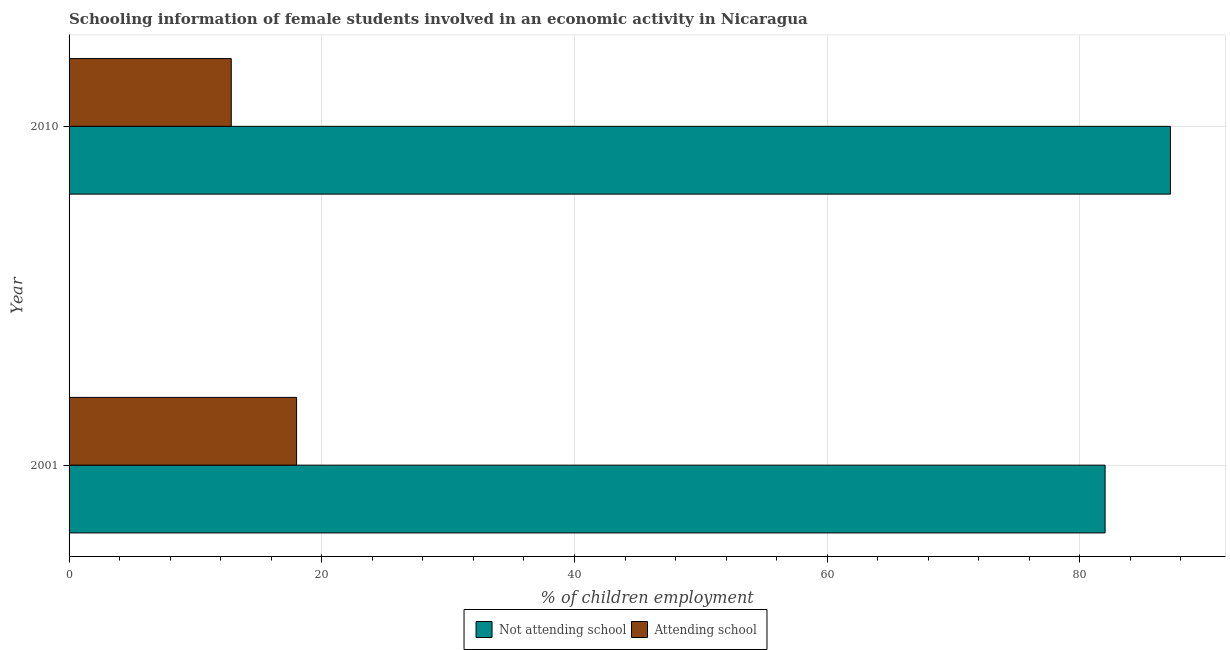How many different coloured bars are there?
Offer a very short reply. 2. Are the number of bars per tick equal to the number of legend labels?
Give a very brief answer. Yes. How many bars are there on the 1st tick from the top?
Provide a short and direct response. 2. What is the label of the 1st group of bars from the top?
Your answer should be compact. 2010. In how many cases, is the number of bars for a given year not equal to the number of legend labels?
Make the answer very short. 0. What is the percentage of employed females who are not attending school in 2001?
Provide a succinct answer. 81.99. Across all years, what is the maximum percentage of employed females who are not attending school?
Your answer should be compact. 87.16. Across all years, what is the minimum percentage of employed females who are attending school?
Provide a succinct answer. 12.84. What is the total percentage of employed females who are not attending school in the graph?
Keep it short and to the point. 169.16. What is the difference between the percentage of employed females who are not attending school in 2001 and that in 2010?
Your response must be concise. -5.17. What is the difference between the percentage of employed females who are attending school in 2010 and the percentage of employed females who are not attending school in 2001?
Ensure brevity in your answer.  -69.16. What is the average percentage of employed females who are not attending school per year?
Provide a succinct answer. 84.58. In the year 2010, what is the difference between the percentage of employed females who are attending school and percentage of employed females who are not attending school?
Offer a terse response. -74.33. What is the ratio of the percentage of employed females who are not attending school in 2001 to that in 2010?
Your response must be concise. 0.94. Is the percentage of employed females who are not attending school in 2001 less than that in 2010?
Ensure brevity in your answer.  Yes. Is the difference between the percentage of employed females who are not attending school in 2001 and 2010 greater than the difference between the percentage of employed females who are attending school in 2001 and 2010?
Your response must be concise. No. In how many years, is the percentage of employed females who are attending school greater than the average percentage of employed females who are attending school taken over all years?
Make the answer very short. 1. What does the 2nd bar from the top in 2001 represents?
Make the answer very short. Not attending school. What does the 1st bar from the bottom in 2001 represents?
Make the answer very short. Not attending school. Does the graph contain any zero values?
Offer a very short reply. No. How many legend labels are there?
Make the answer very short. 2. What is the title of the graph?
Your response must be concise. Schooling information of female students involved in an economic activity in Nicaragua. What is the label or title of the X-axis?
Give a very brief answer. % of children employment. What is the label or title of the Y-axis?
Offer a very short reply. Year. What is the % of children employment of Not attending school in 2001?
Offer a terse response. 81.99. What is the % of children employment of Attending school in 2001?
Your answer should be very brief. 18.01. What is the % of children employment of Not attending school in 2010?
Offer a terse response. 87.16. What is the % of children employment in Attending school in 2010?
Keep it short and to the point. 12.84. Across all years, what is the maximum % of children employment in Not attending school?
Your answer should be compact. 87.16. Across all years, what is the maximum % of children employment in Attending school?
Provide a succinct answer. 18.01. Across all years, what is the minimum % of children employment of Not attending school?
Offer a very short reply. 81.99. Across all years, what is the minimum % of children employment in Attending school?
Ensure brevity in your answer.  12.84. What is the total % of children employment in Not attending school in the graph?
Offer a very short reply. 169.16. What is the total % of children employment in Attending school in the graph?
Your answer should be very brief. 30.84. What is the difference between the % of children employment in Not attending school in 2001 and that in 2010?
Give a very brief answer. -5.17. What is the difference between the % of children employment of Attending school in 2001 and that in 2010?
Ensure brevity in your answer.  5.17. What is the difference between the % of children employment in Not attending school in 2001 and the % of children employment in Attending school in 2010?
Give a very brief answer. 69.16. What is the average % of children employment in Not attending school per year?
Provide a short and direct response. 84.58. What is the average % of children employment of Attending school per year?
Your response must be concise. 15.42. In the year 2001, what is the difference between the % of children employment in Not attending school and % of children employment in Attending school?
Provide a succinct answer. 63.99. In the year 2010, what is the difference between the % of children employment of Not attending school and % of children employment of Attending school?
Your response must be concise. 74.33. What is the ratio of the % of children employment of Not attending school in 2001 to that in 2010?
Offer a very short reply. 0.94. What is the ratio of the % of children employment in Attending school in 2001 to that in 2010?
Your response must be concise. 1.4. What is the difference between the highest and the second highest % of children employment of Not attending school?
Your response must be concise. 5.17. What is the difference between the highest and the second highest % of children employment of Attending school?
Your answer should be compact. 5.17. What is the difference between the highest and the lowest % of children employment of Not attending school?
Offer a terse response. 5.17. What is the difference between the highest and the lowest % of children employment in Attending school?
Your answer should be compact. 5.17. 